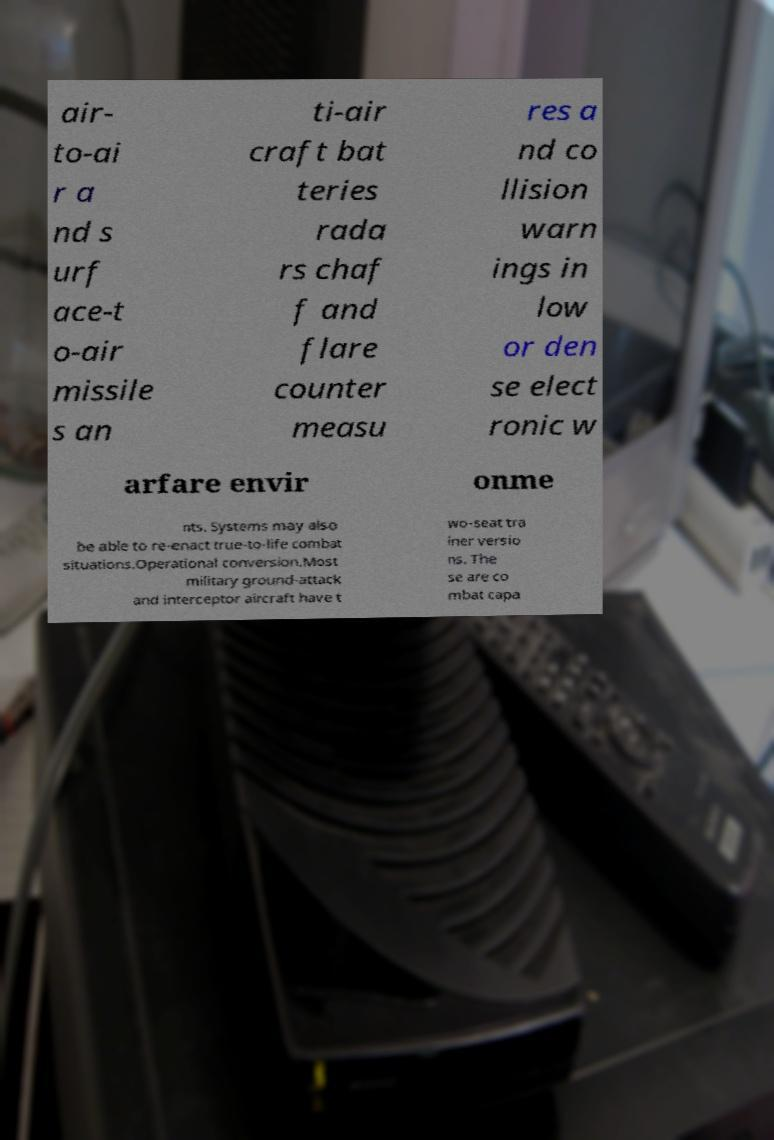Can you read and provide the text displayed in the image?This photo seems to have some interesting text. Can you extract and type it out for me? air- to-ai r a nd s urf ace-t o-air missile s an ti-air craft bat teries rada rs chaf f and flare counter measu res a nd co llision warn ings in low or den se elect ronic w arfare envir onme nts. Systems may also be able to re-enact true-to-life combat situations.Operational conversion.Most military ground-attack and interceptor aircraft have t wo-seat tra iner versio ns. The se are co mbat capa 